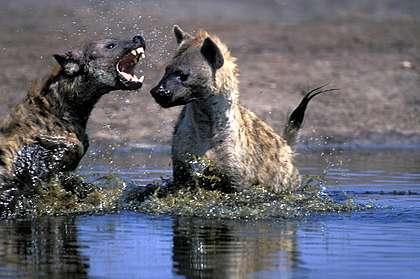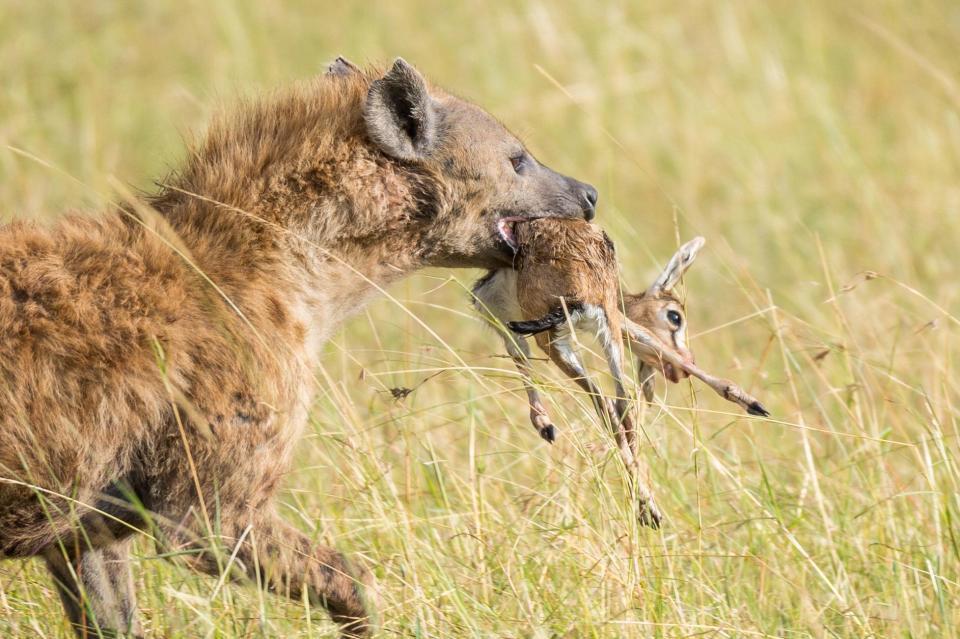The first image is the image on the left, the second image is the image on the right. Examine the images to the left and right. Is the description "At least one hyena is facing right and showing teeth." accurate? Answer yes or no. Yes. The first image is the image on the left, the second image is the image on the right. For the images shown, is this caption "An image shows an open-mouthed lion facing off with at least one hyena." true? Answer yes or no. No. 